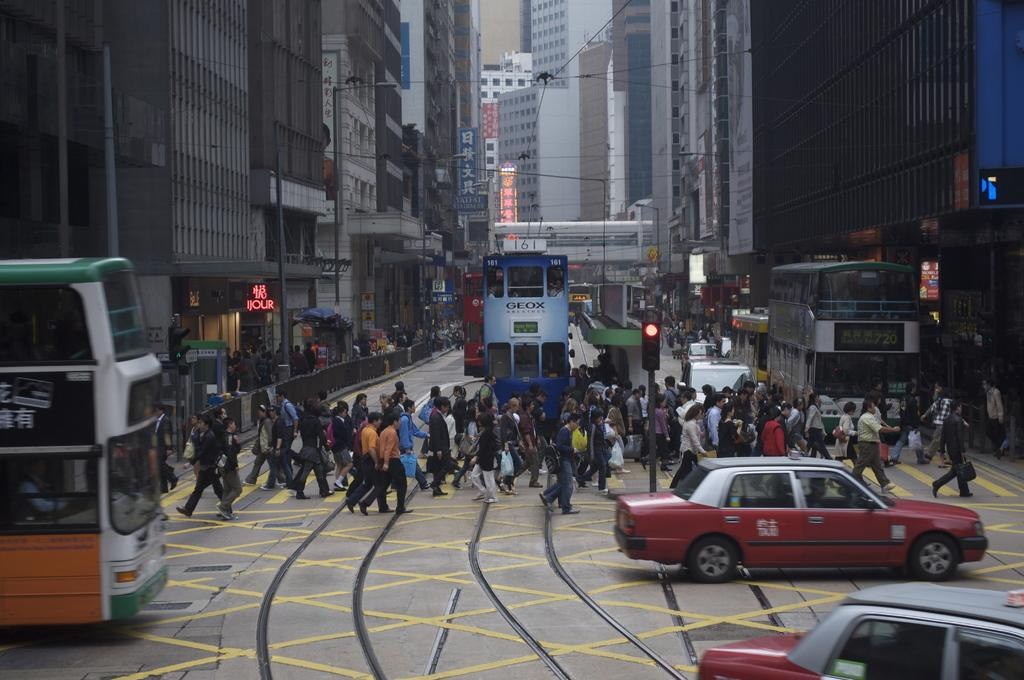<image>
Present a compact description of the photo's key features. A double decker bus with a advertisment that says GEOX 